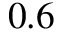<formula> <loc_0><loc_0><loc_500><loc_500>0 . 6</formula> 